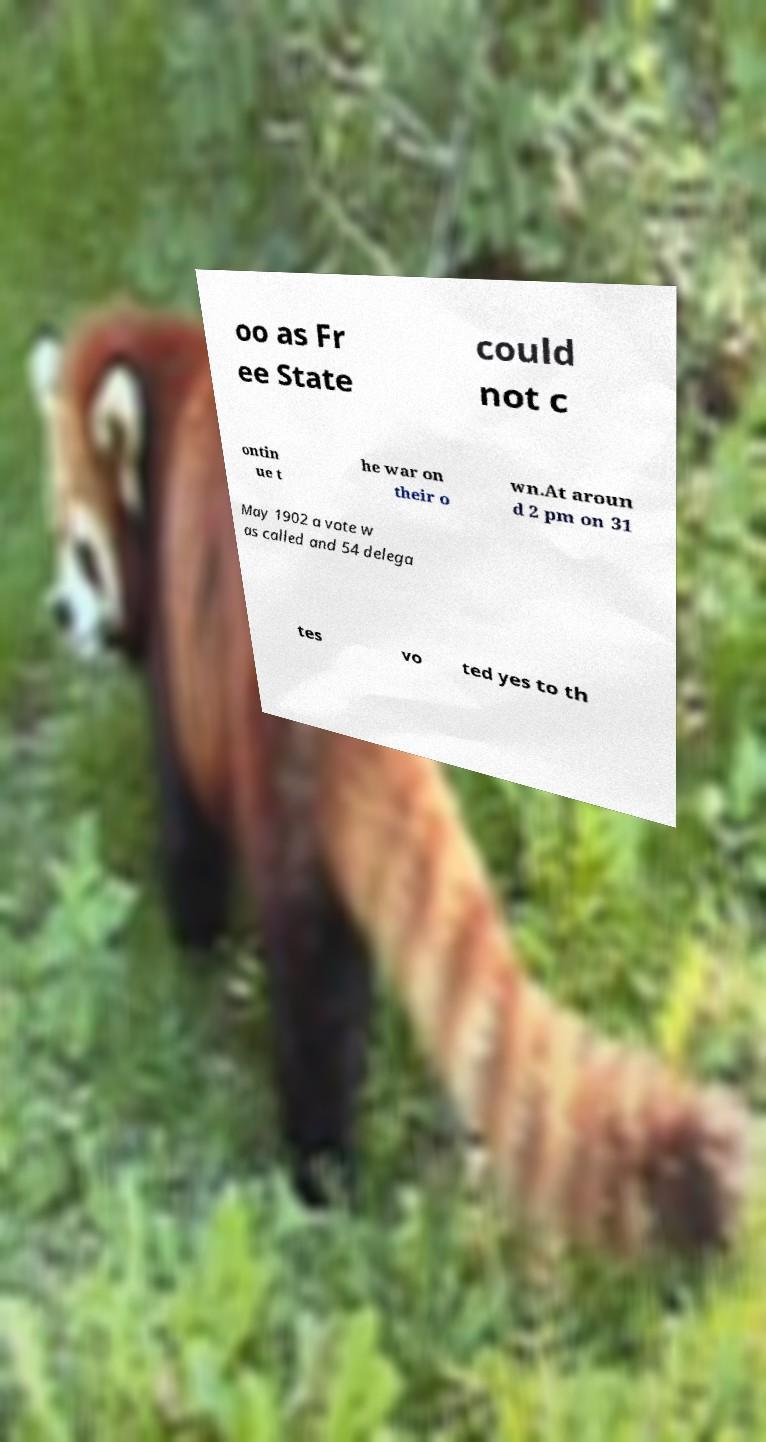Can you read and provide the text displayed in the image?This photo seems to have some interesting text. Can you extract and type it out for me? oo as Fr ee State could not c ontin ue t he war on their o wn.At aroun d 2 pm on 31 May 1902 a vote w as called and 54 delega tes vo ted yes to th 